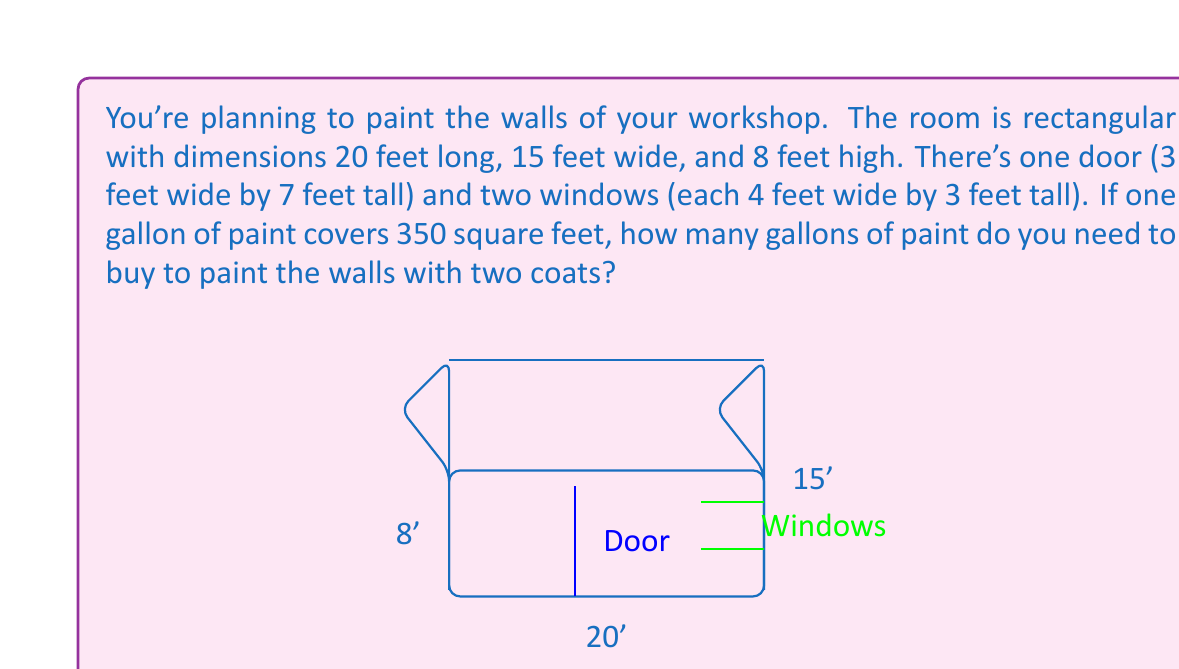Could you help me with this problem? Let's approach this step-by-step:

1) First, calculate the total wall area:
   $$\text{Total wall area} = 2(20 \times 8) + 2(15 \times 8) = 320 + 240 = 560 \text{ sq ft}$$

2) Now, calculate the area of the door and windows:
   $$\text{Door area} = 3 \times 7 = 21 \text{ sq ft}$$
   $$\text{Window area} = 2(4 \times 3) = 24 \text{ sq ft}$$
   $$\text{Total area to subtract} = 21 + 24 = 45 \text{ sq ft}$$

3) Calculate the actual area to be painted:
   $$\text{Area to paint} = 560 - 45 = 515 \text{ sq ft}$$

4) Since you need two coats, double this area:
   $$\text{Total area for two coats} = 515 \times 2 = 1030 \text{ sq ft}$$

5) Now, calculate the number of gallons needed:
   $$\text{Gallons needed} = \frac{1030 \text{ sq ft}}{350 \text{ sq ft/gallon}} \approx 2.94 \text{ gallons}$$

6) Since you can't buy a fraction of a gallon, round up to the nearest whole number:
   $$\text{Gallons to buy} = 3 \text{ gallons}$$
Answer: 3 gallons 